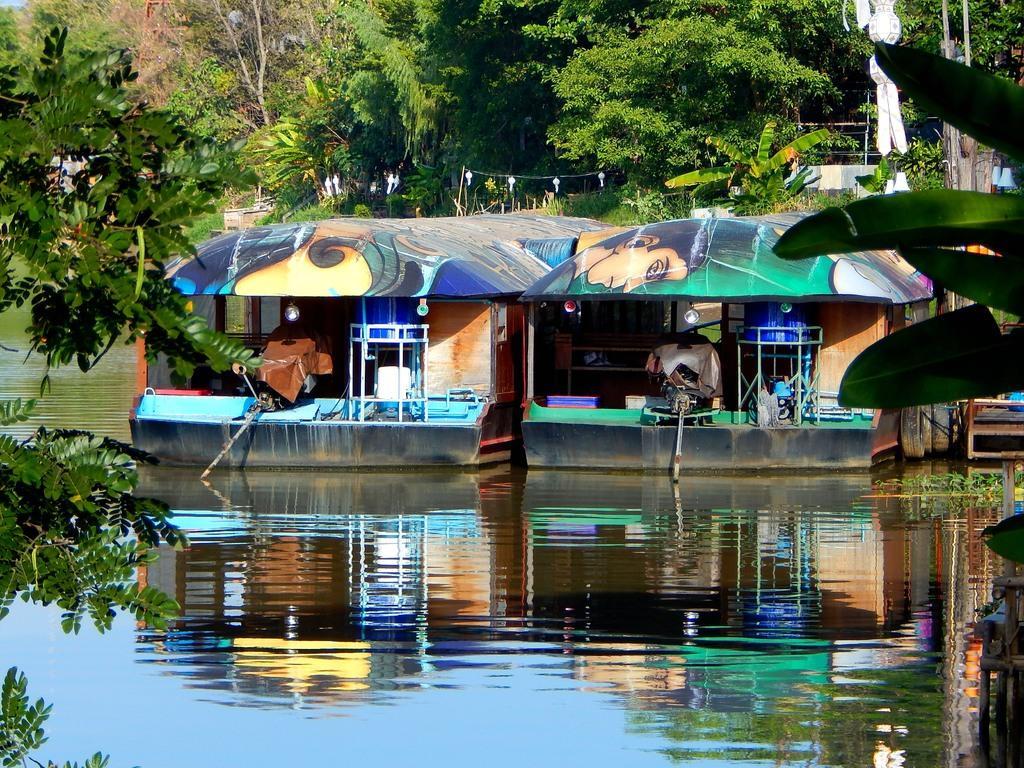Please provide a concise description of this image. In this picture there is a water body. In the center of the picture there are boats. In the background there are trees and plants. In the foreground there are branches of trees. 